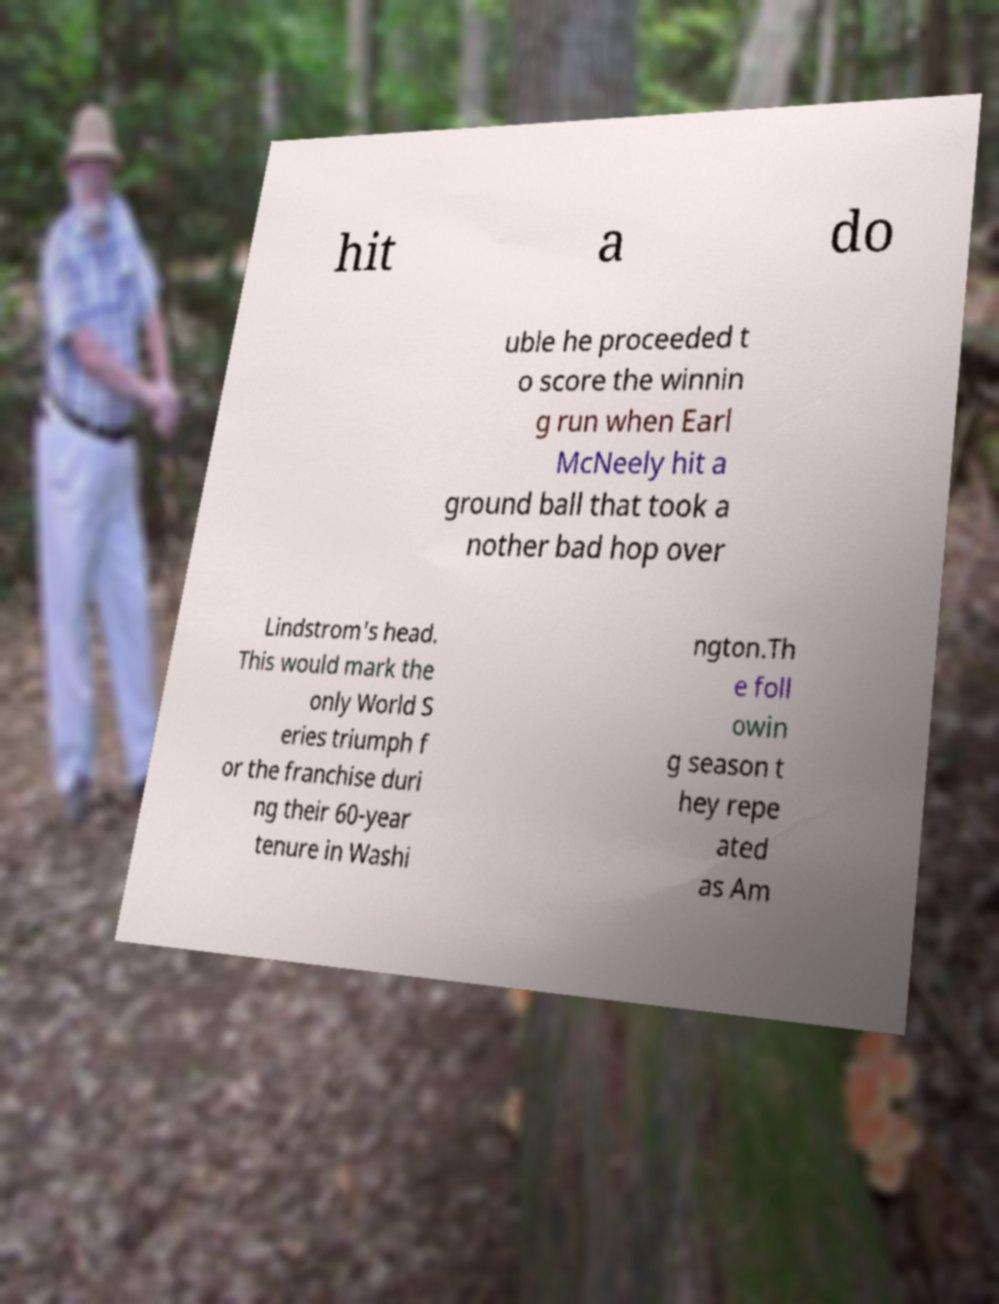What messages or text are displayed in this image? I need them in a readable, typed format. hit a do uble he proceeded t o score the winnin g run when Earl McNeely hit a ground ball that took a nother bad hop over Lindstrom's head. This would mark the only World S eries triumph f or the franchise duri ng their 60-year tenure in Washi ngton.Th e foll owin g season t hey repe ated as Am 